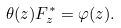<formula> <loc_0><loc_0><loc_500><loc_500>\theta ( z ) F _ { z } ^ { \ast } = \varphi ( z ) .</formula> 